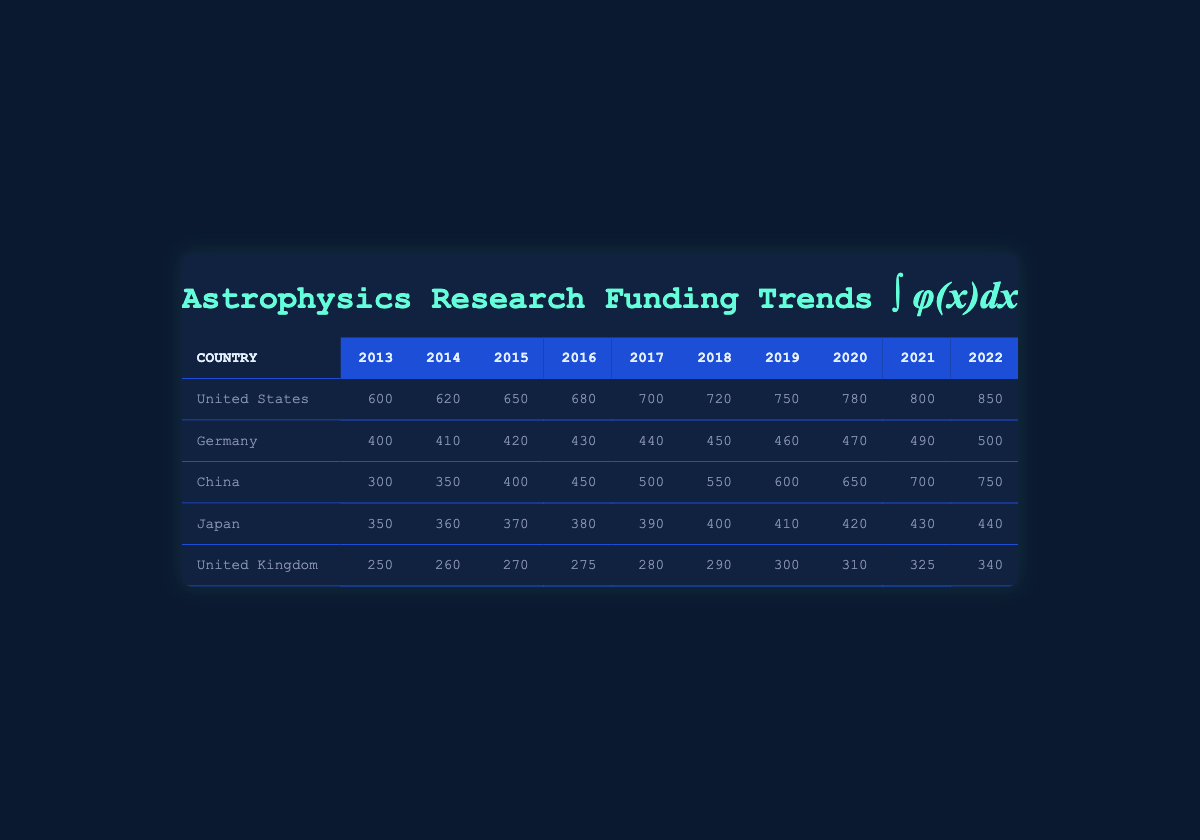What was the highest funding for astrophysics research by the United States in the last decade? The table shows the funding for the United States from 2013 to 2022. The values are: 600, 620, 650, 680, 700, 720, 750, 780, 800, and 850 million USD. The highest value is 850 million USD in 2022.
Answer: 850 million USD Which country received the lowest funding in 2022? In 2022, the funding values for each country are: United States - 850 million USD, Germany - 500 million USD, China - 750 million USD, Japan - 440 million USD, United Kingdom - 340 million USD. The lowest funding is 340 million USD from the United Kingdom.
Answer: United Kingdom What is the total funding for astrophysics research initiatives in Germany over the last decade? The funding amounts for Germany from 2013 to 2022 are: 400, 410, 420, 430, 440, 450, 460, 470, 490, and 500 million USD. Adding them gives: 400 + 410 + 420 + 430 + 440 + 450 + 460 + 470 + 490 + 500 = 4470 million USD.
Answer: 4470 million USD Did China ever have a lower funding amount than Japan in the last decade? From the table, throughout the years 2013 to 2022, China had funding values of 300, 350, 400, 450, 500, 550, 600, 650, 700, and 750 million USD. Japan's funding values are 350, 360, 370, 380, 390, 400, 410, 420, 430, and 440 million USD. In 2013 and 2014, China's funding (300 and 350 million USD) was lower than Japan's (350 and 360 million USD). Thus, there were years when this was true.
Answer: Yes What was the average annual funding growth for the United States over the last decade? To determine the annual growth, we need to calculate the change in funding year-to-year for the US from 2013 to 2022: (620-600), (650-620), (680-650), (700-680), (720-700), (750-720), (780-750), (800-780), (850-800) = 20, 30, 30, 20, 20, 30, 30, 20, 50 respectively. The total growth is 20 + 30 + 30 + 20 + 20 + 30 + 30 + 20 + 50 = 250 million USD over 9 years. The average annual growth is then 250 million USD / 9 ≈ 27.78 million USD.
Answer: 27.78 million USD 